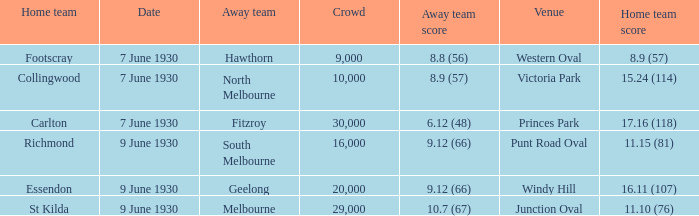Which opposing team played against footscray? Hawthorn. 